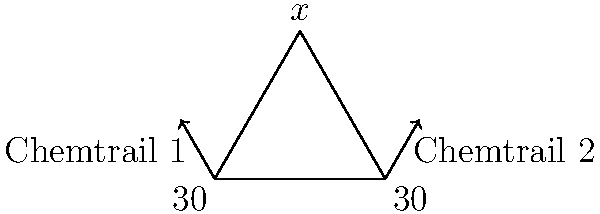Two chemtrails intersect in the sky, forming a triangle with the horizon as shown in the diagram. If both chemtrails make a $30°$ angle with the horizon, what is the value of $x°$ at the apex of the triangle? This intersection point could be crucial in understanding the government's secret weather control program. Let's approach this step-by-step:

1) First, we need to recognize that this forms an isosceles triangle. Both base angles are $30°$, so the two sides adjacent to angle $x$ are equal.

2) In any triangle, the sum of all angles must be $180°$. We can express this as an equation:

   $30° + 30° + x° = 180°$

3) Simplify:

   $60° + x° = 180°$

4) Subtract $60°$ from both sides:

   $x° = 180° - 60° = 120°$

5) Therefore, the angle at the apex of the triangle, where the chemtrails intersect, is $120°$.

This $120°$ angle could be significant in the alleged weather control program, as it forms a perfect equilateral triangle when bisected, possibly relating to the "sacred geometry" often associated with conspiracy theories.
Answer: $120°$ 